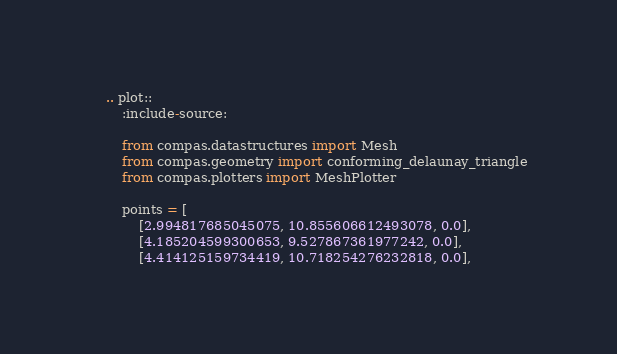Convert code to text. <code><loc_0><loc_0><loc_500><loc_500><_Python_>    .. plot::
        :include-source:

        from compas.datastructures import Mesh
        from compas.geometry import conforming_delaunay_triangle
        from compas.plotters import MeshPlotter

        points = [
            [2.994817685045075, 10.855606612493078, 0.0],
            [4.185204599300653, 9.527867361977242, 0.0],
            [4.414125159734419, 10.718254276232818, 0.0],</code> 